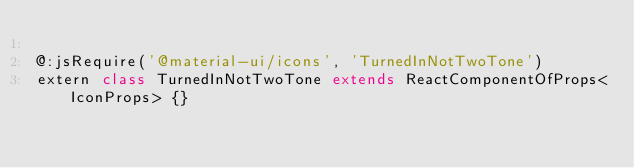<code> <loc_0><loc_0><loc_500><loc_500><_Haxe_>
@:jsRequire('@material-ui/icons', 'TurnedInNotTwoTone')
extern class TurnedInNotTwoTone extends ReactComponentOfProps<IconProps> {}
</code> 